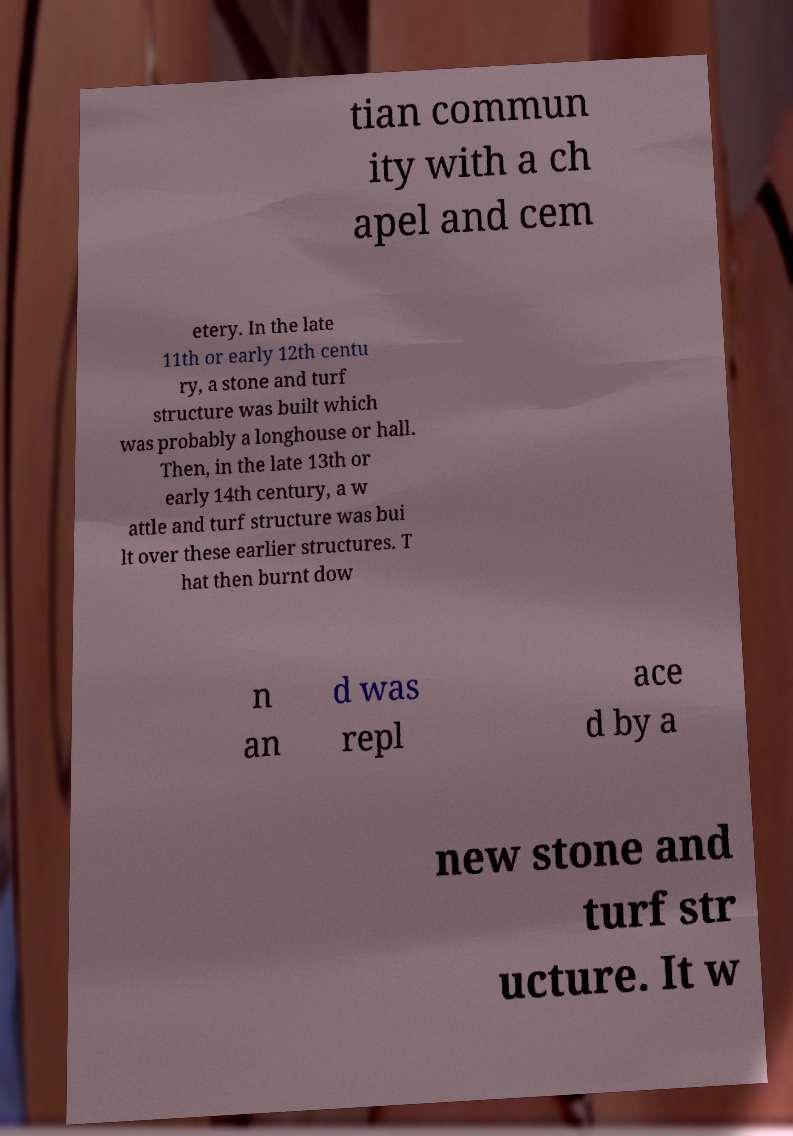For documentation purposes, I need the text within this image transcribed. Could you provide that? tian commun ity with a ch apel and cem etery. In the late 11th or early 12th centu ry, a stone and turf structure was built which was probably a longhouse or hall. Then, in the late 13th or early 14th century, a w attle and turf structure was bui lt over these earlier structures. T hat then burnt dow n an d was repl ace d by a new stone and turf str ucture. It w 